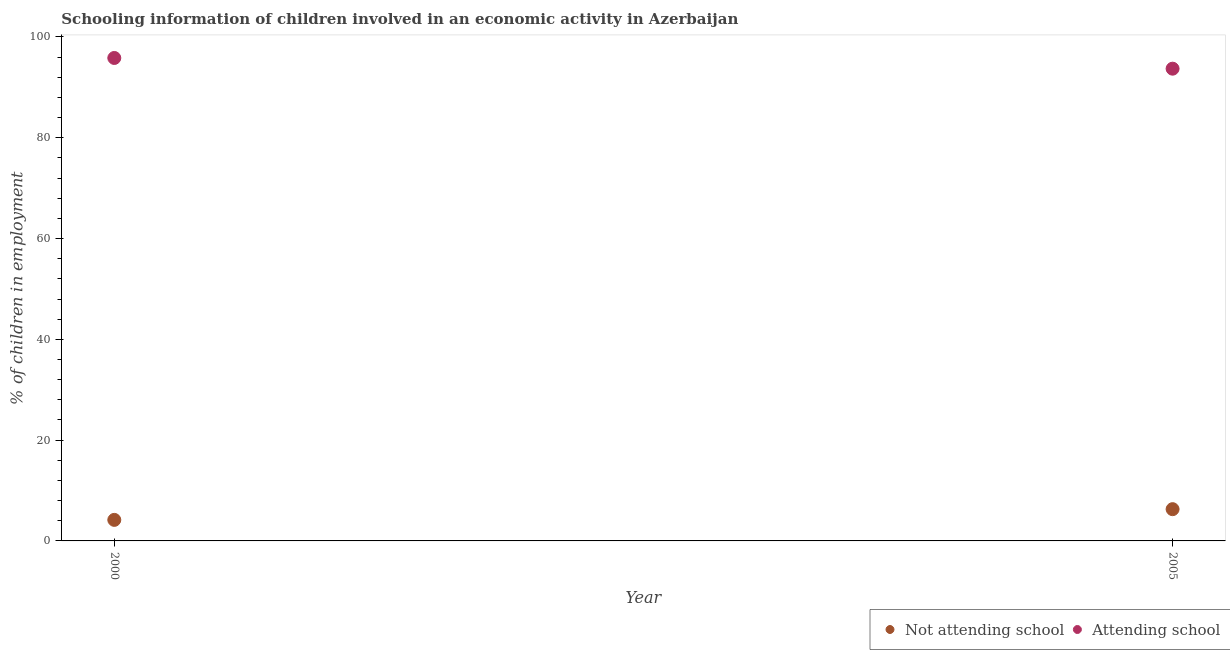How many different coloured dotlines are there?
Provide a succinct answer. 2. What is the percentage of employed children who are attending school in 2000?
Your answer should be compact. 95.82. Across all years, what is the maximum percentage of employed children who are not attending school?
Your response must be concise. 6.3. Across all years, what is the minimum percentage of employed children who are not attending school?
Your response must be concise. 4.18. In which year was the percentage of employed children who are attending school minimum?
Your response must be concise. 2005. What is the total percentage of employed children who are attending school in the graph?
Offer a terse response. 189.52. What is the difference between the percentage of employed children who are attending school in 2000 and that in 2005?
Offer a very short reply. 2.12. What is the difference between the percentage of employed children who are not attending school in 2000 and the percentage of employed children who are attending school in 2005?
Provide a short and direct response. -89.52. What is the average percentage of employed children who are not attending school per year?
Provide a succinct answer. 5.24. In the year 2005, what is the difference between the percentage of employed children who are attending school and percentage of employed children who are not attending school?
Offer a terse response. 87.4. In how many years, is the percentage of employed children who are attending school greater than 20 %?
Your answer should be compact. 2. What is the ratio of the percentage of employed children who are not attending school in 2000 to that in 2005?
Make the answer very short. 0.66. Is the percentage of employed children who are attending school in 2000 less than that in 2005?
Provide a succinct answer. No. In how many years, is the percentage of employed children who are not attending school greater than the average percentage of employed children who are not attending school taken over all years?
Your response must be concise. 1. Is the percentage of employed children who are attending school strictly greater than the percentage of employed children who are not attending school over the years?
Make the answer very short. Yes. How many years are there in the graph?
Your answer should be very brief. 2. Are the values on the major ticks of Y-axis written in scientific E-notation?
Your response must be concise. No. Does the graph contain any zero values?
Provide a short and direct response. No. Does the graph contain grids?
Ensure brevity in your answer.  No. How many legend labels are there?
Provide a short and direct response. 2. What is the title of the graph?
Give a very brief answer. Schooling information of children involved in an economic activity in Azerbaijan. What is the label or title of the X-axis?
Your answer should be very brief. Year. What is the label or title of the Y-axis?
Keep it short and to the point. % of children in employment. What is the % of children in employment of Not attending school in 2000?
Make the answer very short. 4.18. What is the % of children in employment of Attending school in 2000?
Provide a short and direct response. 95.82. What is the % of children in employment in Not attending school in 2005?
Provide a short and direct response. 6.3. What is the % of children in employment in Attending school in 2005?
Your answer should be very brief. 93.7. Across all years, what is the maximum % of children in employment in Not attending school?
Your answer should be very brief. 6.3. Across all years, what is the maximum % of children in employment in Attending school?
Ensure brevity in your answer.  95.82. Across all years, what is the minimum % of children in employment of Not attending school?
Give a very brief answer. 4.18. Across all years, what is the minimum % of children in employment in Attending school?
Make the answer very short. 93.7. What is the total % of children in employment in Not attending school in the graph?
Make the answer very short. 10.48. What is the total % of children in employment of Attending school in the graph?
Provide a succinct answer. 189.52. What is the difference between the % of children in employment in Not attending school in 2000 and that in 2005?
Give a very brief answer. -2.12. What is the difference between the % of children in employment of Attending school in 2000 and that in 2005?
Ensure brevity in your answer.  2.12. What is the difference between the % of children in employment in Not attending school in 2000 and the % of children in employment in Attending school in 2005?
Make the answer very short. -89.52. What is the average % of children in employment of Not attending school per year?
Make the answer very short. 5.24. What is the average % of children in employment in Attending school per year?
Your answer should be compact. 94.76. In the year 2000, what is the difference between the % of children in employment of Not attending school and % of children in employment of Attending school?
Make the answer very short. -91.65. In the year 2005, what is the difference between the % of children in employment of Not attending school and % of children in employment of Attending school?
Offer a very short reply. -87.4. What is the ratio of the % of children in employment of Not attending school in 2000 to that in 2005?
Give a very brief answer. 0.66. What is the ratio of the % of children in employment of Attending school in 2000 to that in 2005?
Ensure brevity in your answer.  1.02. What is the difference between the highest and the second highest % of children in employment in Not attending school?
Keep it short and to the point. 2.12. What is the difference between the highest and the second highest % of children in employment of Attending school?
Keep it short and to the point. 2.12. What is the difference between the highest and the lowest % of children in employment of Not attending school?
Give a very brief answer. 2.12. What is the difference between the highest and the lowest % of children in employment in Attending school?
Ensure brevity in your answer.  2.12. 